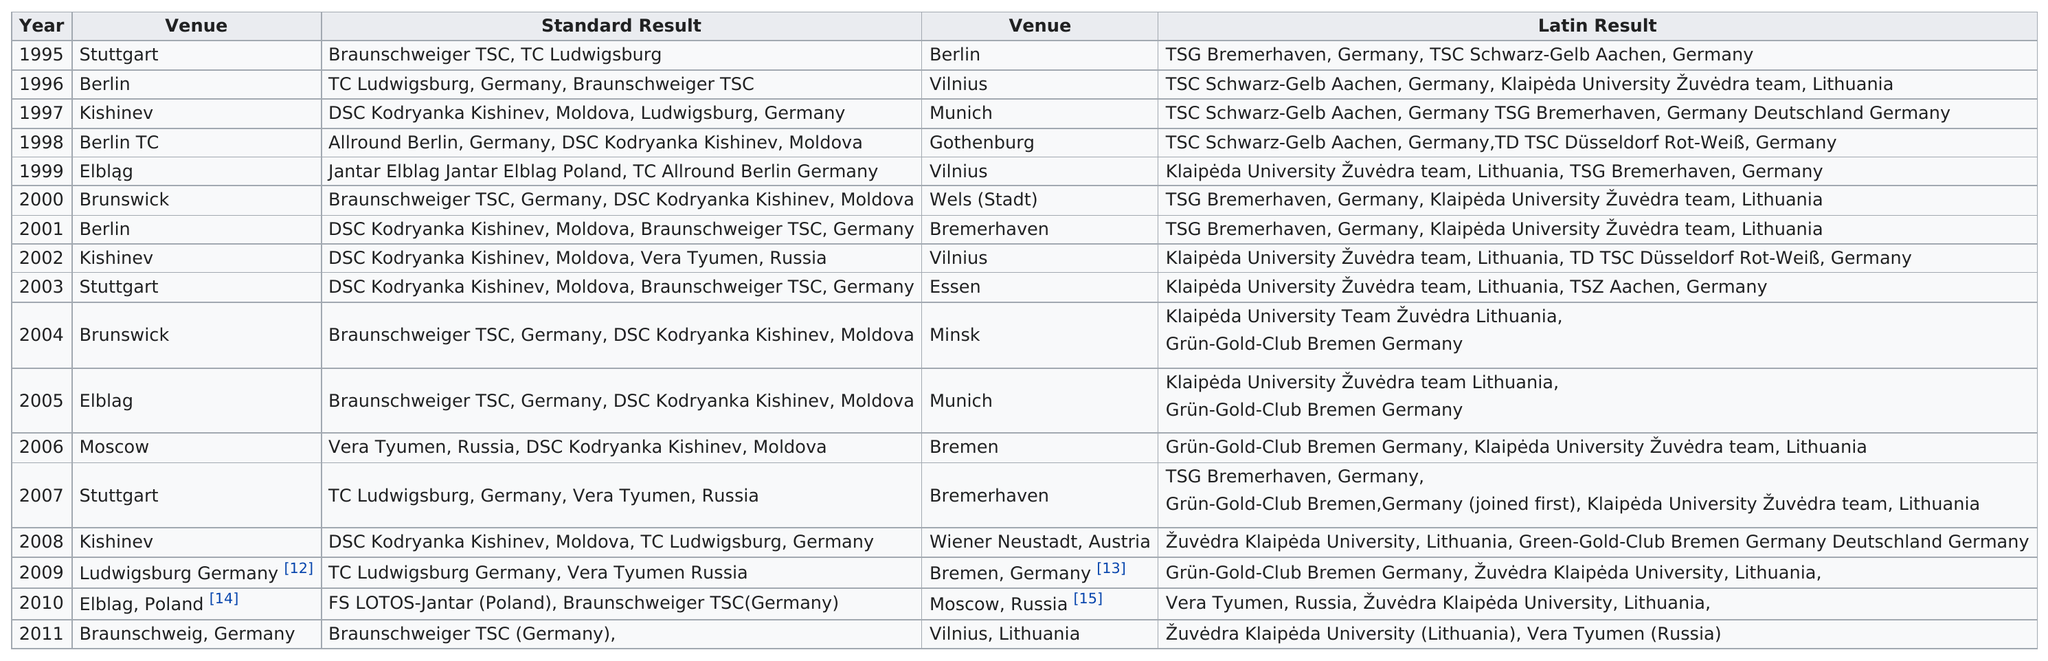Draw attention to some important aspects in this diagram. Kishinev hosted the standard result immediately after Berlin in the 1990s. Bremen was the venue for the IDSF World Championships for the Latin result two times. 